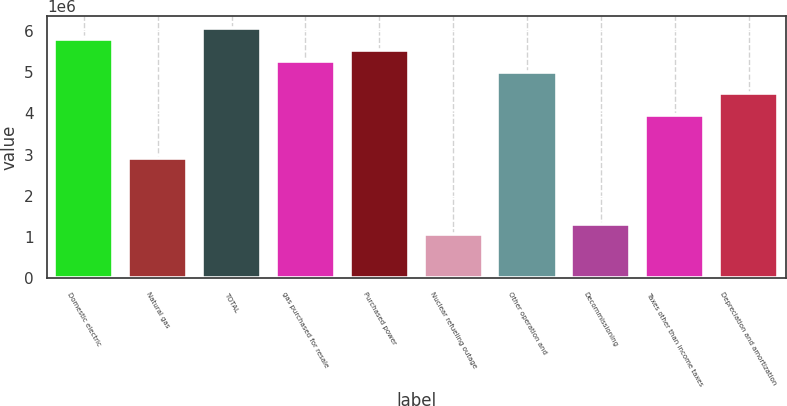Convert chart to OTSL. <chart><loc_0><loc_0><loc_500><loc_500><bar_chart><fcel>Domestic electric<fcel>Natural gas<fcel>TOTAL<fcel>gas purchased for resale<fcel>Purchased power<fcel>Nuclear refueling outage<fcel>Other operation and<fcel>Decommissioning<fcel>Taxes other than income taxes<fcel>Depreciation and amortization<nl><fcel>5.80445e+06<fcel>2.90346e+06<fcel>6.06818e+06<fcel>5.277e+06<fcel>5.54072e+06<fcel>1.05738e+06<fcel>5.01327e+06<fcel>1.32111e+06<fcel>3.95837e+06<fcel>4.48582e+06<nl></chart> 